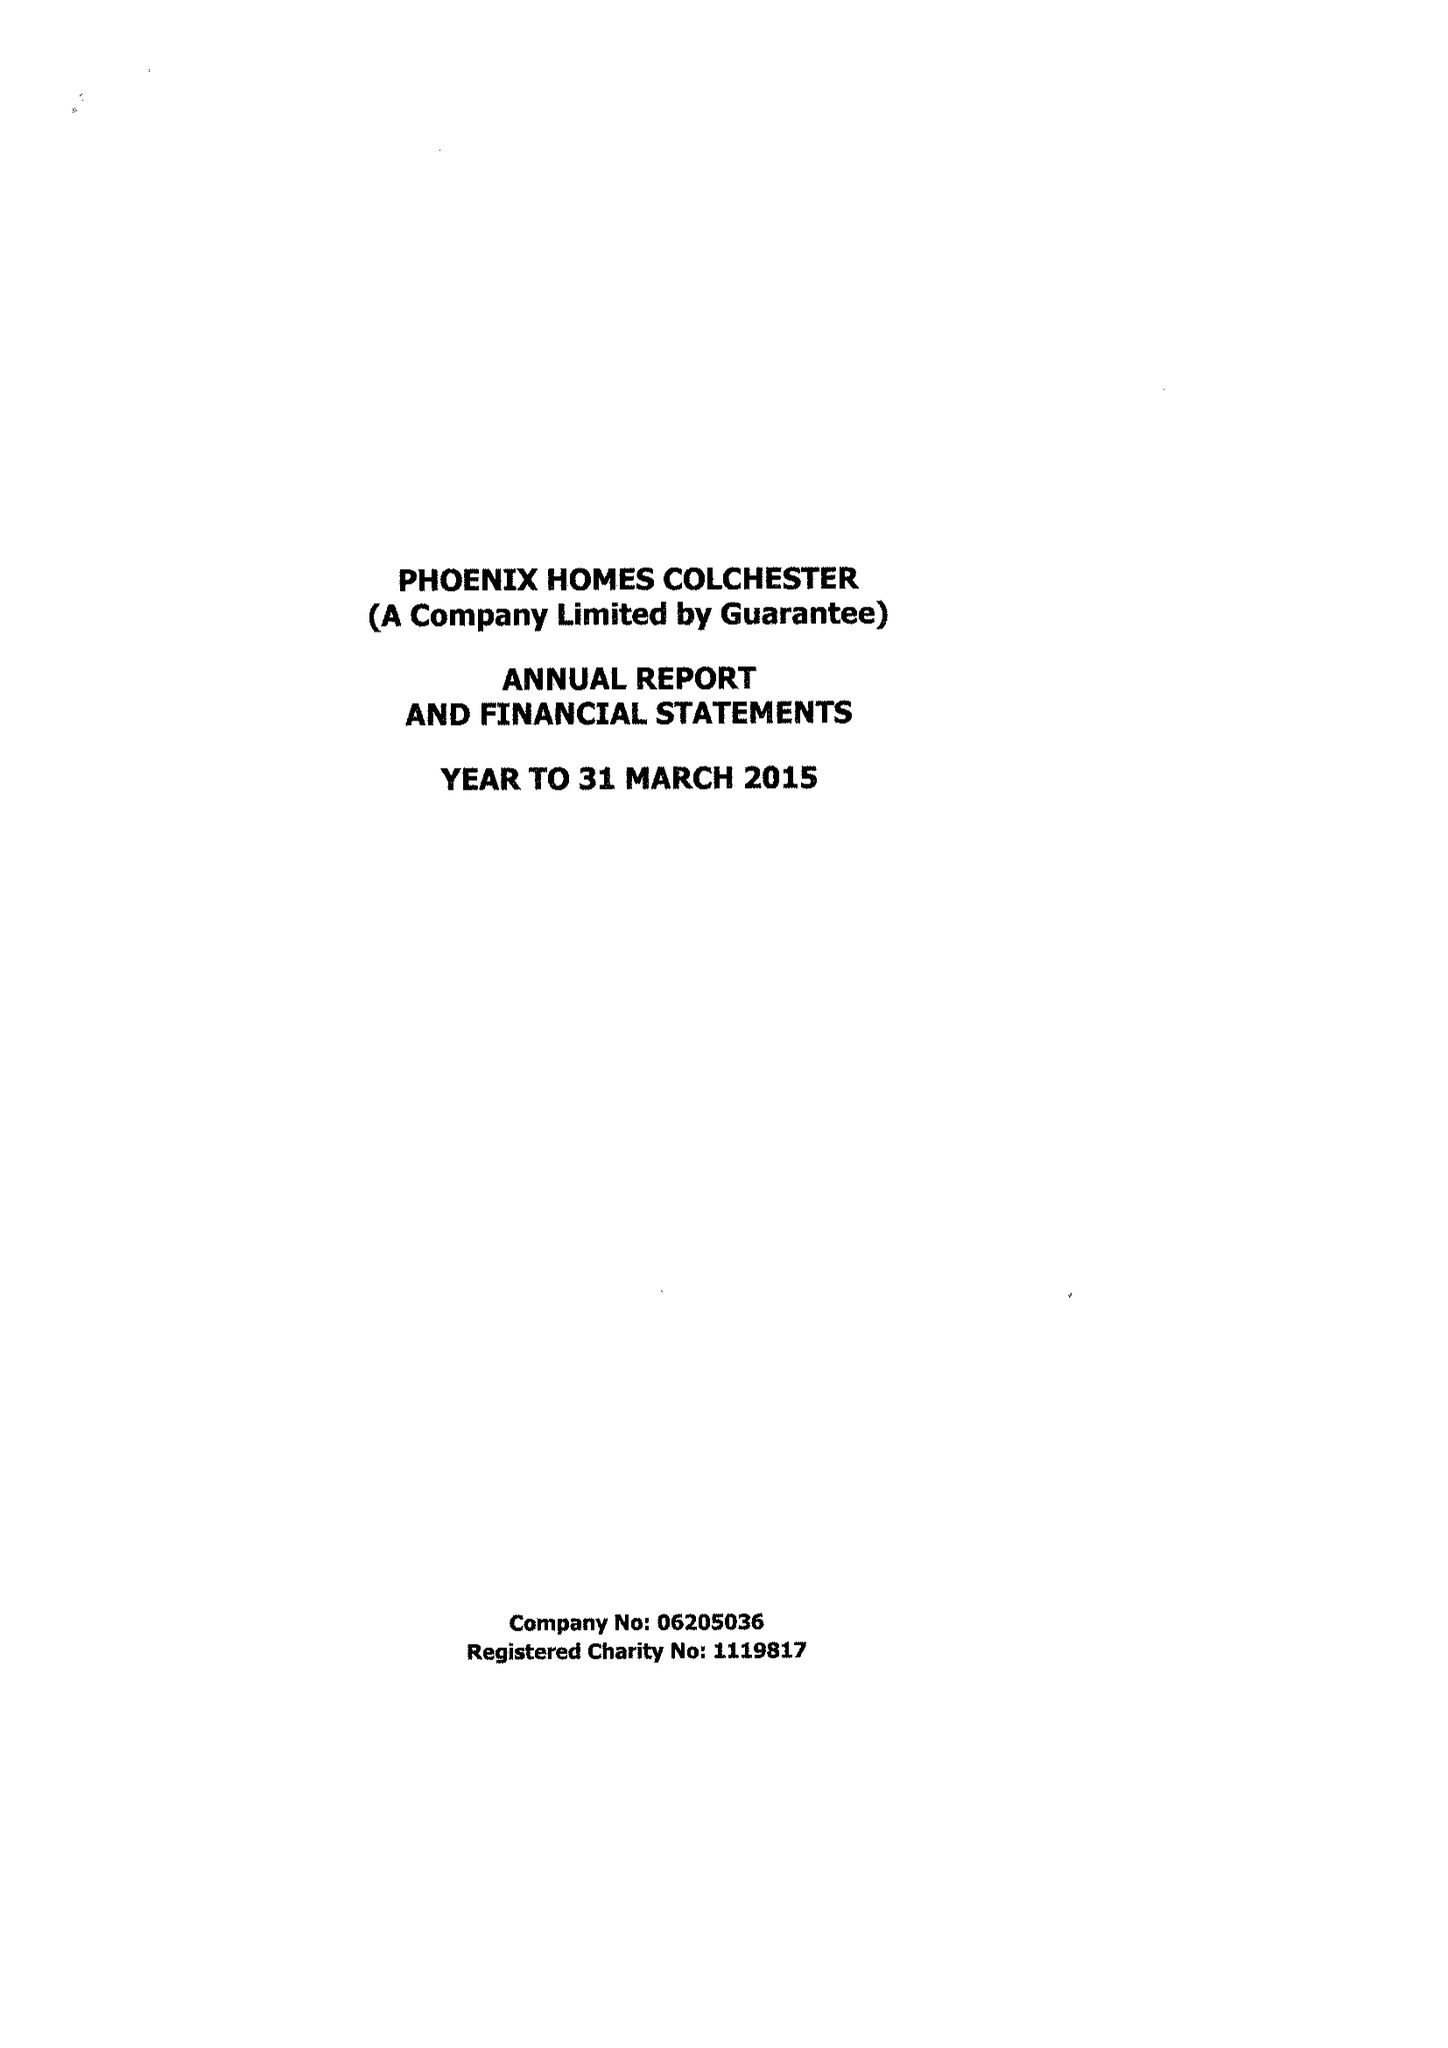What is the value for the address__street_line?
Answer the question using a single word or phrase. 147 STRAIGHT ROAD 